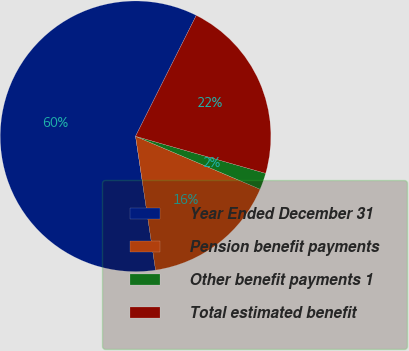Convert chart. <chart><loc_0><loc_0><loc_500><loc_500><pie_chart><fcel>Year Ended December 31<fcel>Pension benefit payments<fcel>Other benefit payments 1<fcel>Total estimated benefit<nl><fcel>59.77%<fcel>16.24%<fcel>1.98%<fcel>22.01%<nl></chart> 